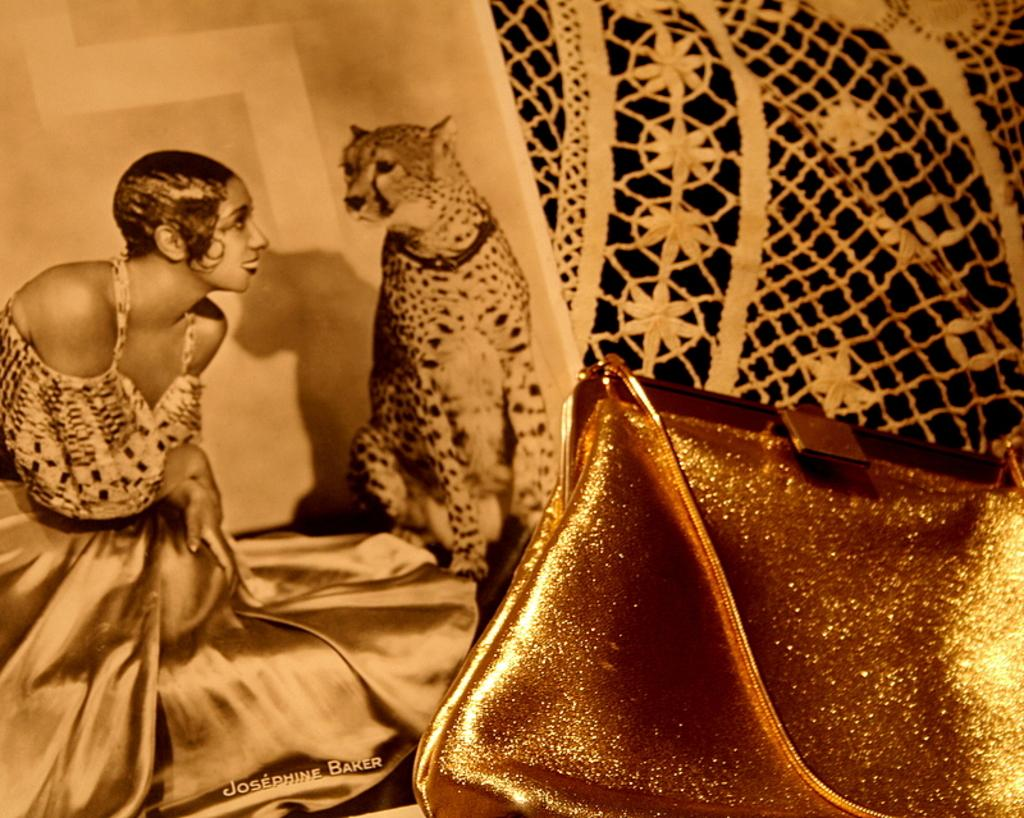What is depicted on the poster in the image? There is a poster of women and a cheetah in the image. What other object can be seen in the image besides the poster? There is a woman's handbag on the side of the image. What type of furniture is present in the image? There is no furniture present in the image; it only features a poster and a handbag. How many cheetah cubs can be seen in the image? There are no cheetah cubs present in the image; it only features a single cheetah. 